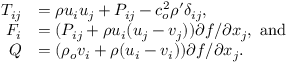<formula> <loc_0><loc_0><loc_500><loc_500>\begin{array} { r l } { T _ { i j } } & { = \rho u _ { i } u _ { j } + P _ { i j } - c _ { o } ^ { 2 } \rho ^ { \prime } \delta _ { i j } , } \\ { F _ { i } } & { = ( P _ { i j } + \rho u _ { i } ( u _ { j } - v _ { j } ) ) { \partial f } / { \partial x _ { j } } , a n d } \\ { Q } & { = ( \rho _ { o } v _ { i } + \rho ( u _ { i } - v _ { i } ) ) { \partial f } / { \partial x _ { j } } . } \end{array}</formula> 